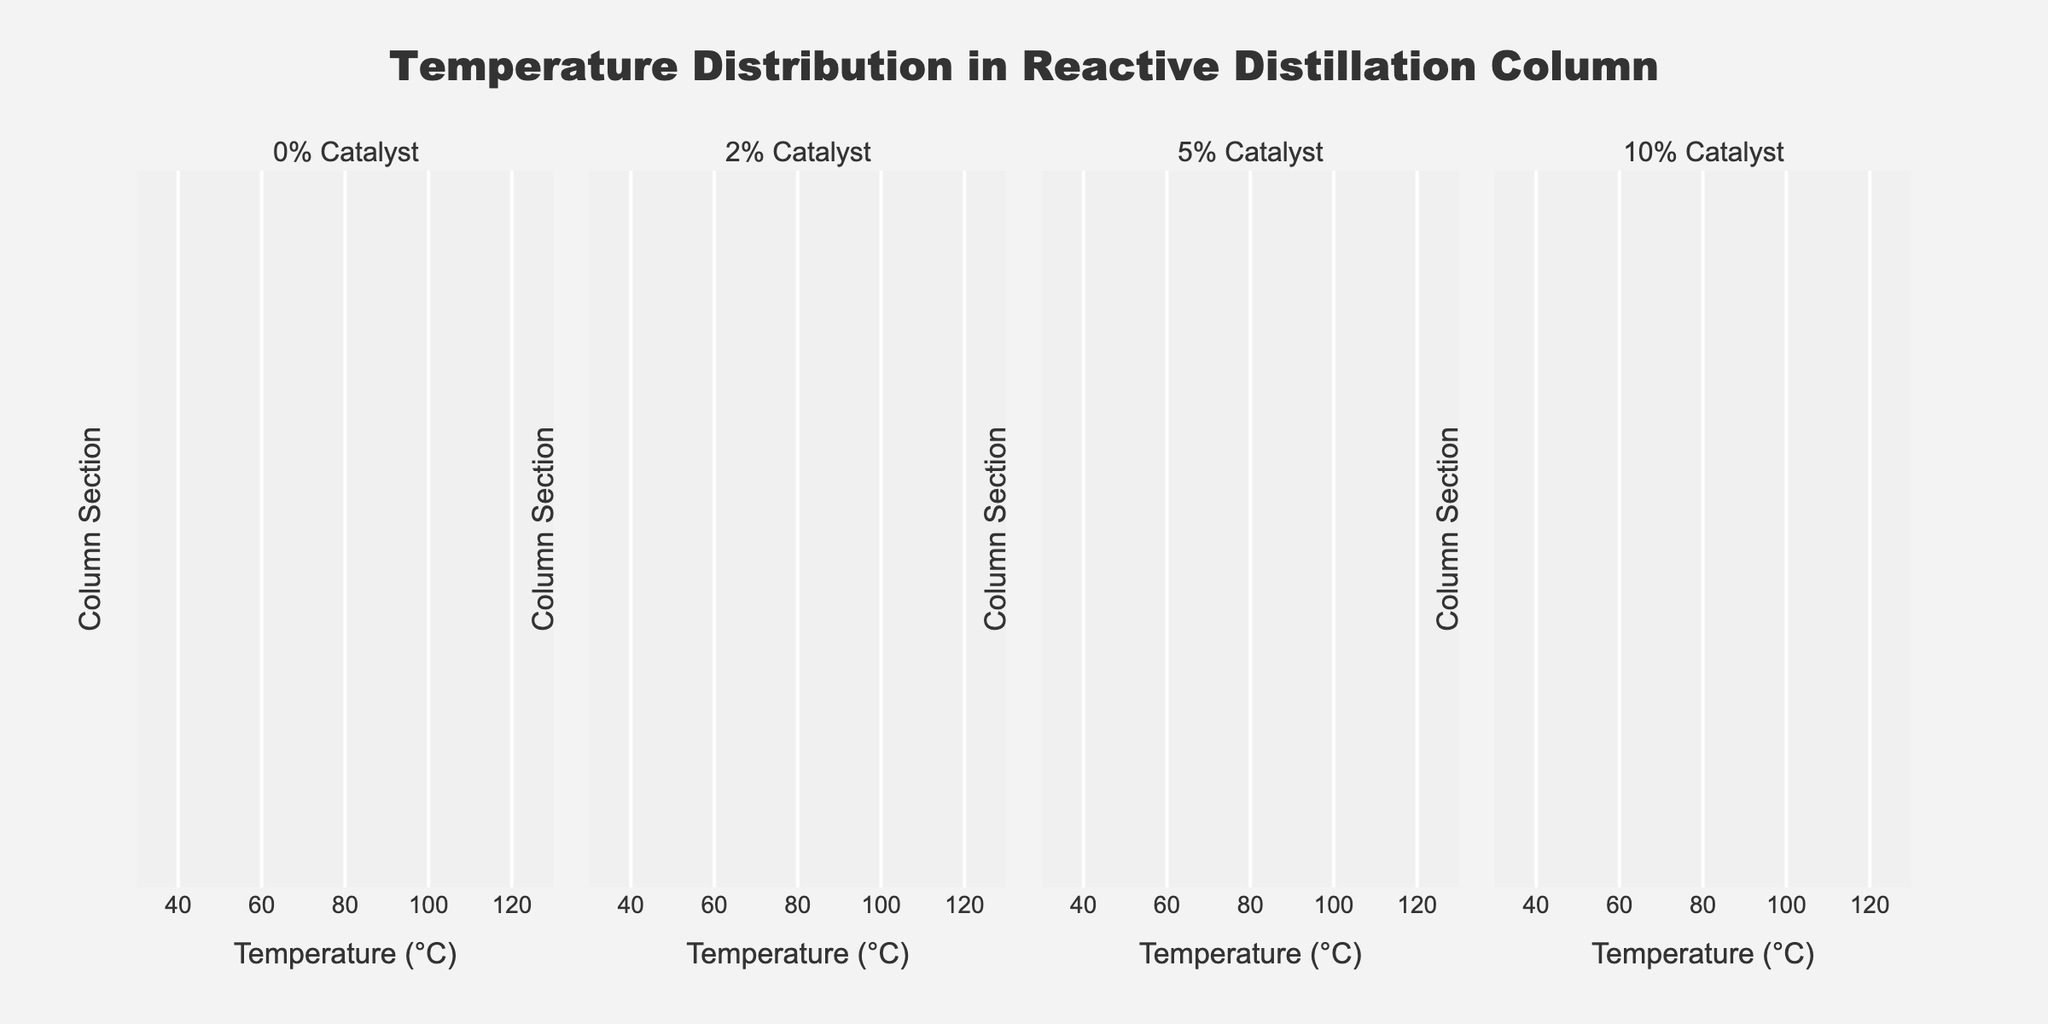How many subplots are there in the figure? By counting the number of distinct panels in the figure, which are labeled with different catalyst loadings, we can determine the number of subplots.
Answer: 4 What is the temperature at the Top Tray for the 10% Catalyst subplot? Navigate to the subplot titled '10% Catalyst'. Then, find the data point corresponding to the Top Tray and read its temperature value.
Answer: 58°C How does the temperature at the Reactive Zone change from 0% Catalyst to 10% Catalyst? Compare the temperature values at the Reactive Zone across the subplots: 75°C (0% Catalyst), 78°C (2% Catalyst), 80°C (5% Catalyst), and 83°C (10% Catalyst).
Answer: It increases Which catalyst loading results in the highest temperature at the Reboiler? Check the temperature values at the Reboiler across all subplots: 120°C (0% Catalyst), 118°C (2% Catalyst), 115°C (5% Catalyst), and 110°C (10% Catalyst).
Answer: 0% Catalyst What is the average temperature difference between the Feed Tray and Top Tray for the 5% Catalyst subplot? For the 5% Catalyst subplot, subtract the Top Tray temperature (60°C) from the Feed Tray temperature (85°C) and calculate the average of their differences: (85 - 60) = 25°C.
Answer: 25°C Which section of the column shows the largest temperature decrease as catalyst loading goes from 0% to 10%? Compare the temperature values for each section from 0% Catalyst to 10% Catalyst, and calculate the differences: Reboiler (10°C), Bottom Tray (8°C), Feed Tray (8°C), Reactive Zone (-8°C), Top Tray (7°C), Condenser (3°C). The Reboiler shows the most significant decrease.
Answer: Reboiler What catalyst loading results in the lowest temperature at the Condenser? Compare the temperature values at the Condenser across all subplots: 40°C (0% Catalyst), 39°C (2% Catalyst), 38°C (5% Catalyst), 37°C (10% Catalyst).
Answer: 10% Catalyst How does the trend of temperatures from Reboiler to Condenser generally change with increasing catalyst loading? Following the trend of temperatures from Reboiler to Condenser as catalyst loading increases, they are mostly decreasing, except for fluctuations in the Reactive Zone values.
Answer: Decreases What is the temperature difference between the Reactive Zone and Bottom Tray for 2% Catalyst? For the 2% Catalyst subplot, subtract the Bottom Tray temperature (103°C) from the Reactive Zone temperature (78°C): (103 - 78) = 25°C.
Answer: 25°C 